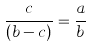<formula> <loc_0><loc_0><loc_500><loc_500>\frac { c } { ( b - c ) } = \frac { a } { b }</formula> 